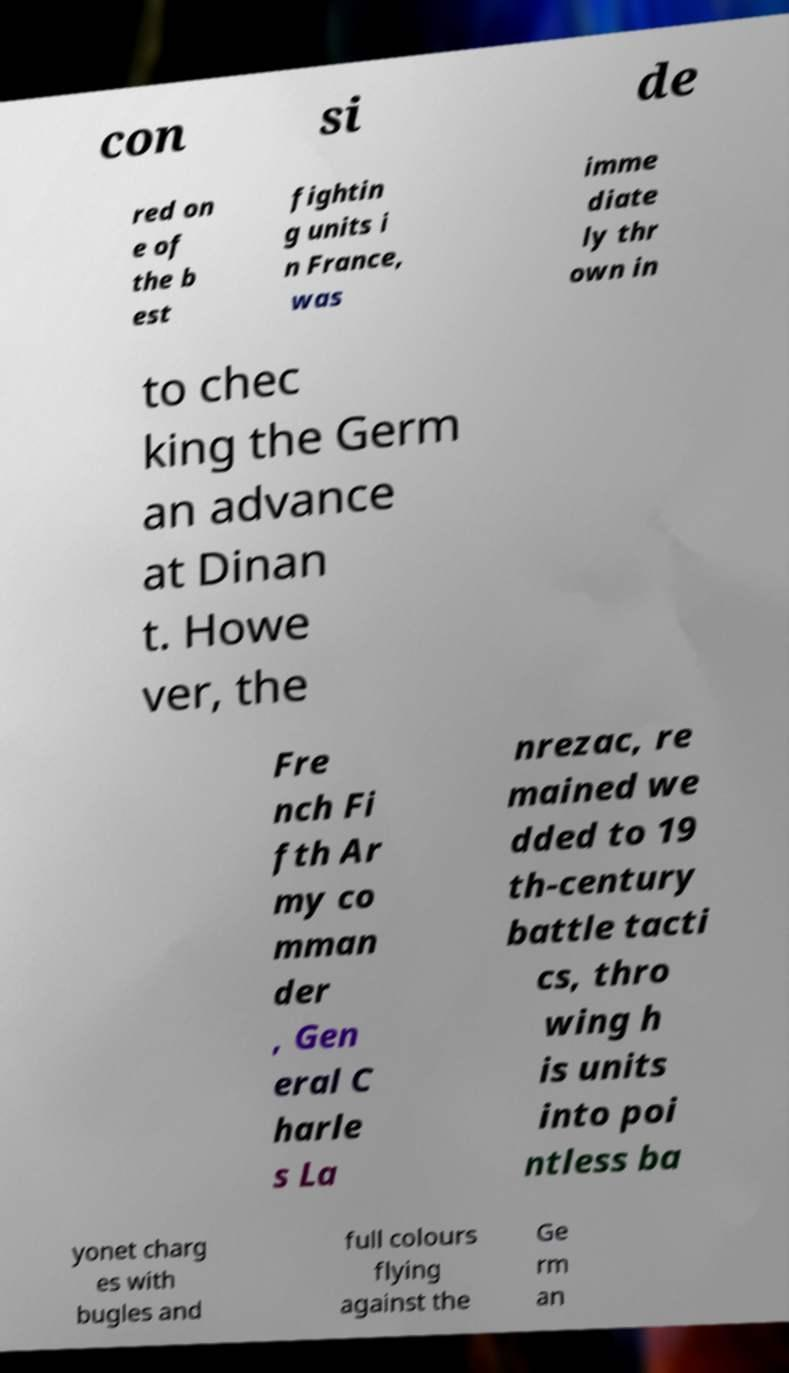Can you read and provide the text displayed in the image?This photo seems to have some interesting text. Can you extract and type it out for me? con si de red on e of the b est fightin g units i n France, was imme diate ly thr own in to chec king the Germ an advance at Dinan t. Howe ver, the Fre nch Fi fth Ar my co mman der , Gen eral C harle s La nrezac, re mained we dded to 19 th-century battle tacti cs, thro wing h is units into poi ntless ba yonet charg es with bugles and full colours flying against the Ge rm an 